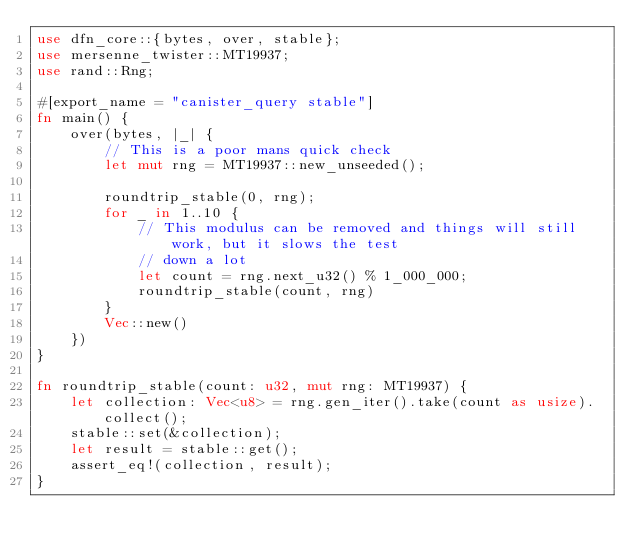Convert code to text. <code><loc_0><loc_0><loc_500><loc_500><_Rust_>use dfn_core::{bytes, over, stable};
use mersenne_twister::MT19937;
use rand::Rng;

#[export_name = "canister_query stable"]
fn main() {
    over(bytes, |_| {
        // This is a poor mans quick check
        let mut rng = MT19937::new_unseeded();

        roundtrip_stable(0, rng);
        for _ in 1..10 {
            // This modulus can be removed and things will still work, but it slows the test
            // down a lot
            let count = rng.next_u32() % 1_000_000;
            roundtrip_stable(count, rng)
        }
        Vec::new()
    })
}

fn roundtrip_stable(count: u32, mut rng: MT19937) {
    let collection: Vec<u8> = rng.gen_iter().take(count as usize).collect();
    stable::set(&collection);
    let result = stable::get();
    assert_eq!(collection, result);
}
</code> 